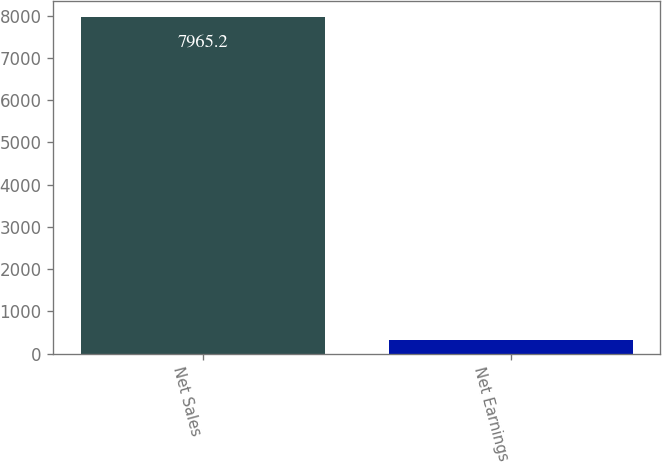Convert chart. <chart><loc_0><loc_0><loc_500><loc_500><bar_chart><fcel>Net Sales<fcel>Net Earnings<nl><fcel>7965.2<fcel>314.5<nl></chart> 